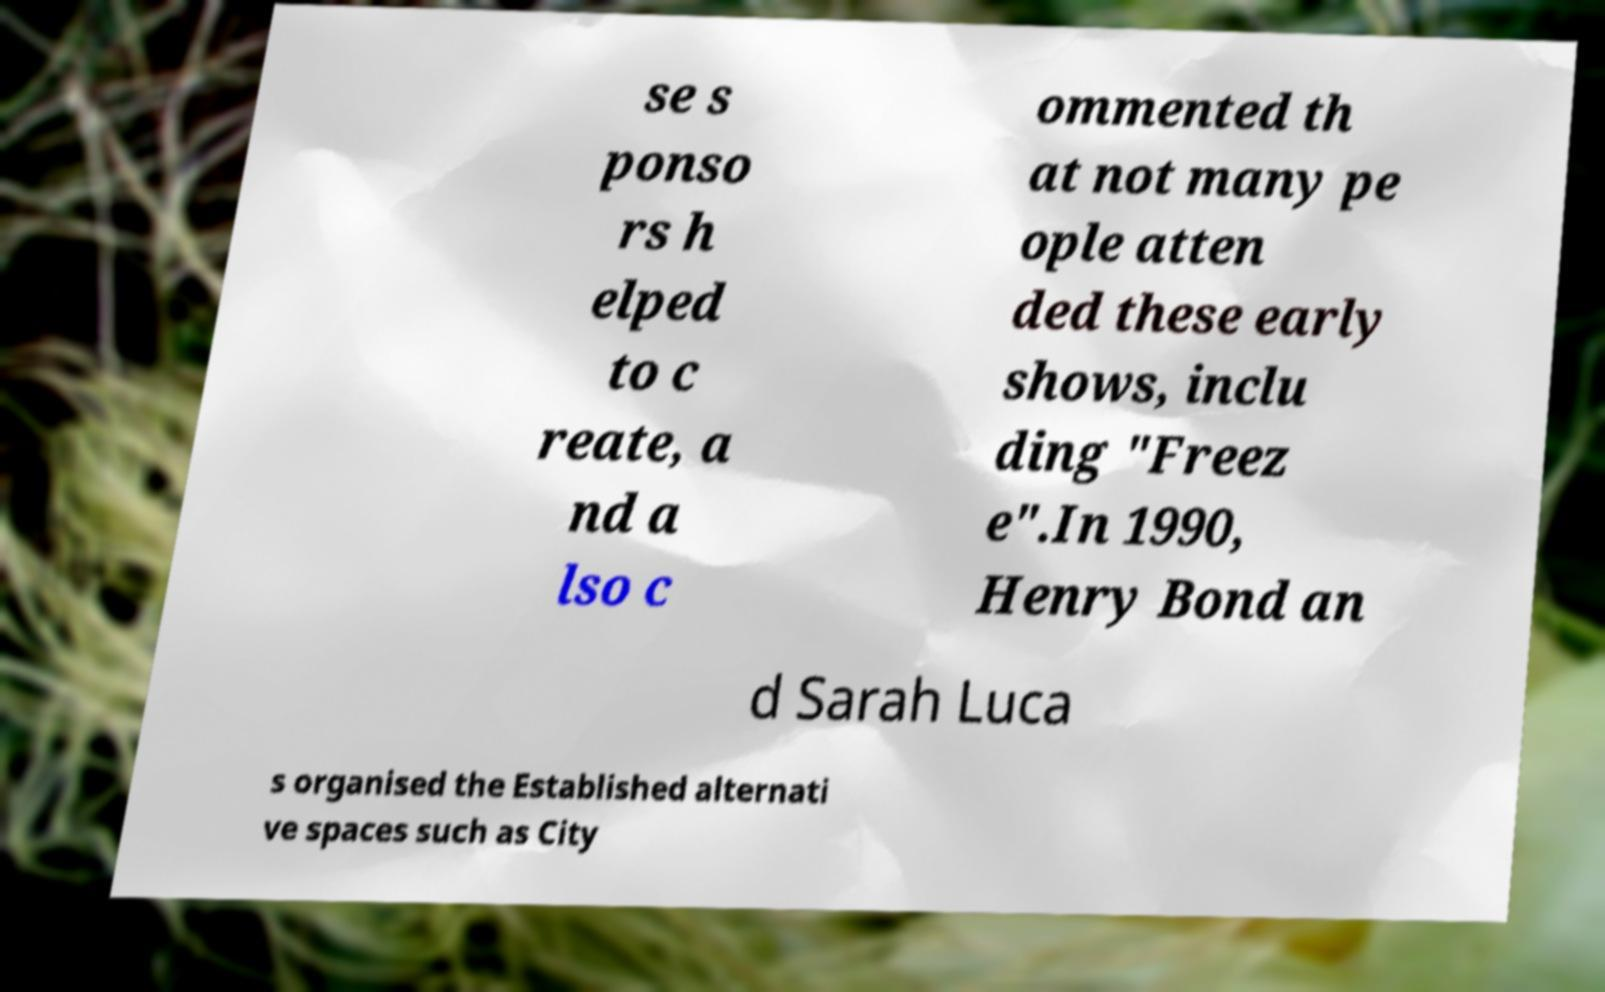Please read and relay the text visible in this image. What does it say? se s ponso rs h elped to c reate, a nd a lso c ommented th at not many pe ople atten ded these early shows, inclu ding "Freez e".In 1990, Henry Bond an d Sarah Luca s organised the Established alternati ve spaces such as City 